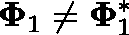Convert formula to latex. <formula><loc_0><loc_0><loc_500><loc_500>\Phi _ { 1 } \neq \Phi _ { 1 } ^ { * }</formula> 